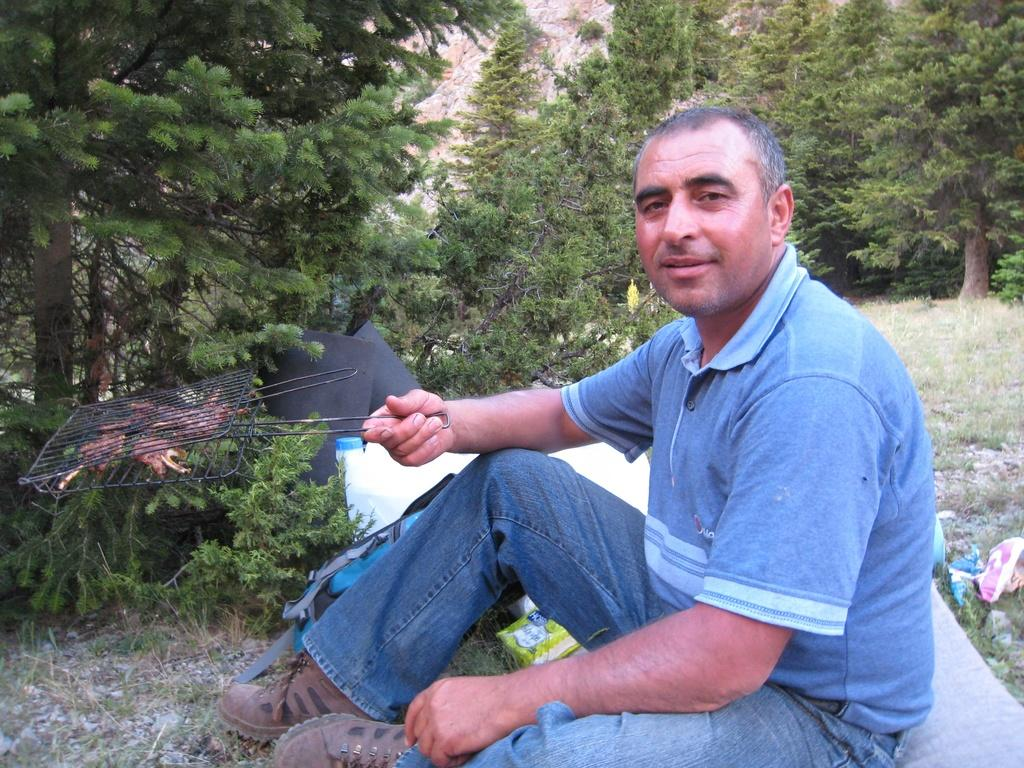Where was the image taken? The image was clicked outside. What is the main subject of the image? There is a person in the middle of the image. What is the person doing in the image? The person is sitting. What can be seen in the background of the image? There are trees visible at the top of the image. Can you see a plough in the image? No, there is no plough present in the image. Are there any bubbles visible around the person in the image? No, there are no bubbles visible in the image. 